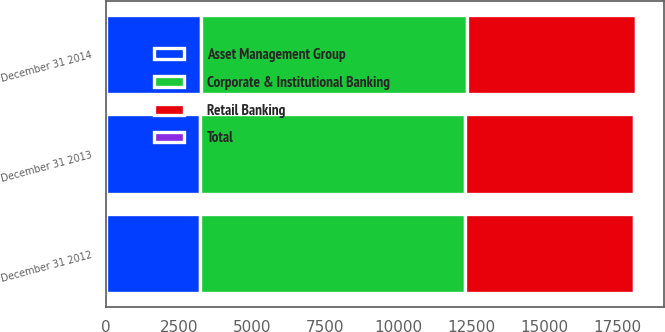Convert chart to OTSL. <chart><loc_0><loc_0><loc_500><loc_500><stacked_bar_chart><ecel><fcel>December 31 2012<fcel>December 31 2013<fcel>December 31 2014<nl><fcel>Retail Banking<fcel>5794<fcel>5795<fcel>5795<nl><fcel>Asset Management Group<fcel>3214<fcel>3215<fcel>3244<nl><fcel>Total<fcel>64<fcel>64<fcel>64<nl><fcel>Corporate & Institutional Banking<fcel>9072<fcel>9074<fcel>9103<nl></chart> 